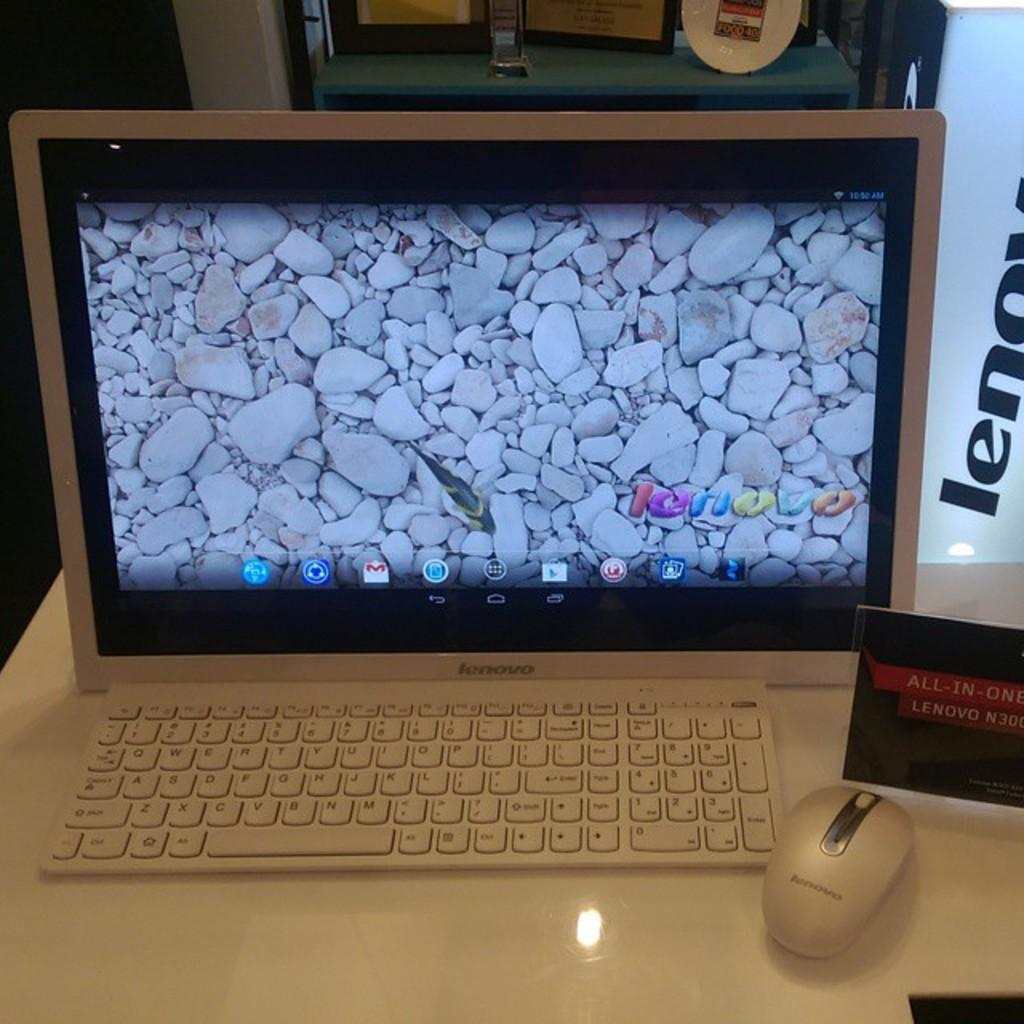<image>
Create a compact narrative representing the image presented. a computer with a word next to it that starts with len 